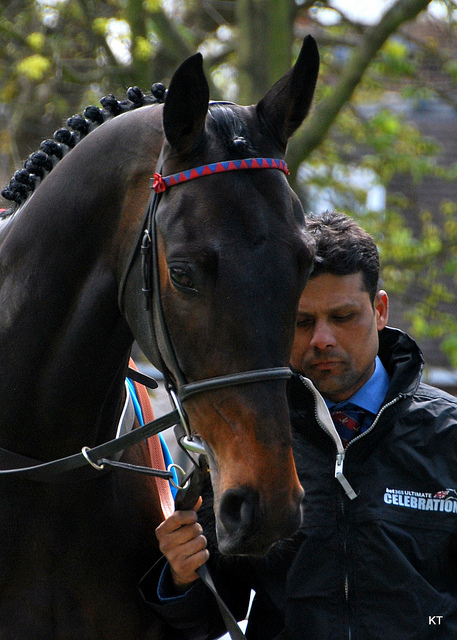Identify and read out the text in this image. KT ULTIMATE CELEBRATION 